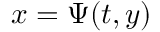<formula> <loc_0><loc_0><loc_500><loc_500>x = \Psi ( t , y )</formula> 